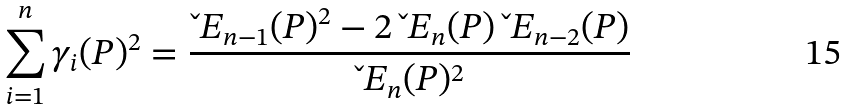<formula> <loc_0><loc_0><loc_500><loc_500>\sum _ { i = 1 } ^ { n } \gamma _ { i } ( P ) ^ { 2 } = \frac { \L E _ { n - 1 } ( P ) ^ { 2 } - 2 \, \L E _ { n } ( P ) \, \L E _ { n - 2 } ( P ) } { \L E _ { n } ( P ) ^ { 2 } }</formula> 